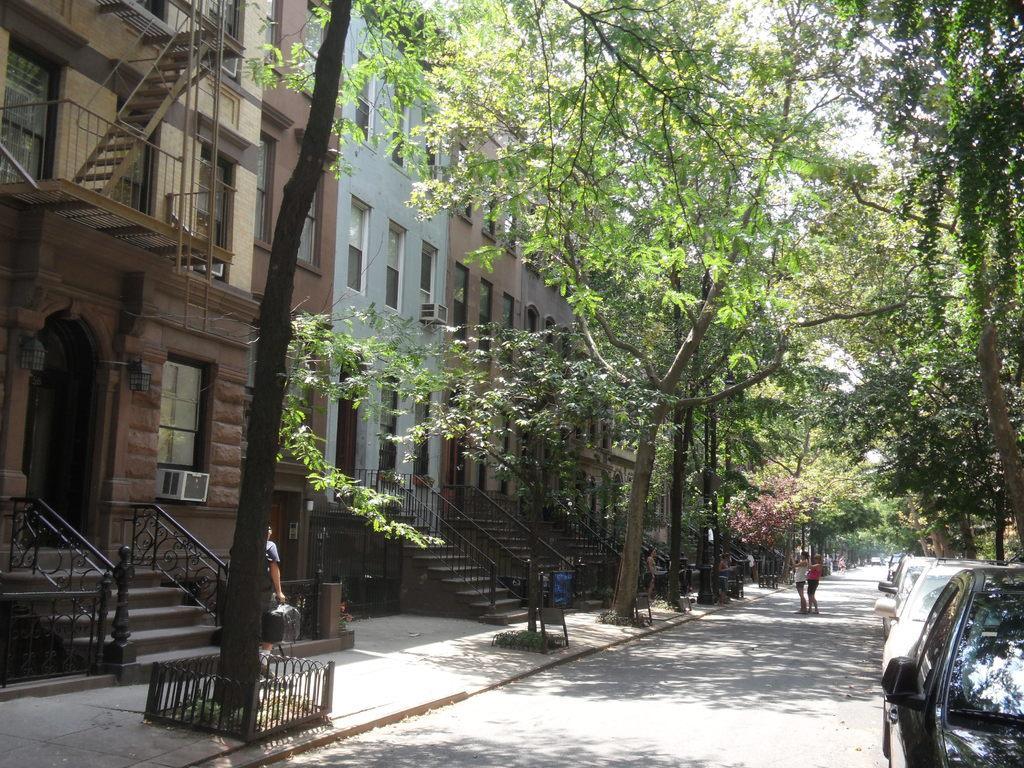Could you give a brief overview of what you see in this image? At the bottom of the image on the road there are cars. Beside the road on the footpath there are trees. And on the left side of the image there are buildings with walls, windows, arched, doors, steps and railings. In the background there are many trees. 